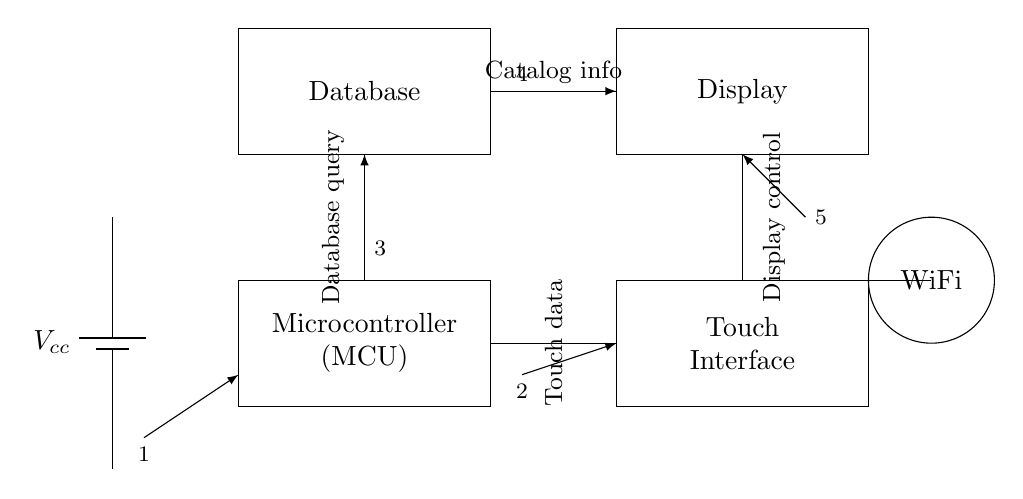What is the main component of this circuit? The main component, represented as a rectangle with the label "Microcontroller," is essential for processing information and controlling the system.
Answer: Microcontroller How many distinct components are present in the circuit? The circuit contains five distinct components: a battery, microcontroller, touch interface, database, and display.
Answer: Five What type of connection is indicated between the microcontroller and the touch interface? The connection is indicated by a line connecting the two components, suggesting a data transfer pathway, which is characteristic of a digital communication interface.
Answer: Data transfer What is the first step in the reading order of this circuit? The first step in the reading order is the battery supplying power to the microcontroller, as indicated by the directed line starting from the battery to the microcontroller.
Answer: Battery to microcontroller What does the WiFi module do in this circuit? The WiFi module is used for wireless communication, allowing the microcontroller to connect to remote databases or services, providing access to additional catalog information.
Answer: Wireless communication Which two components are connected to the database component? The database is connected to the microcontroller above and the display below, as indicated by the drawn lines moving toward these components.
Answer: Microcontroller and display How many connections are made to the display? The display has one direct connection to the database and one from the microcontroller, showing that it receives control signals from both sources.
Answer: Two 